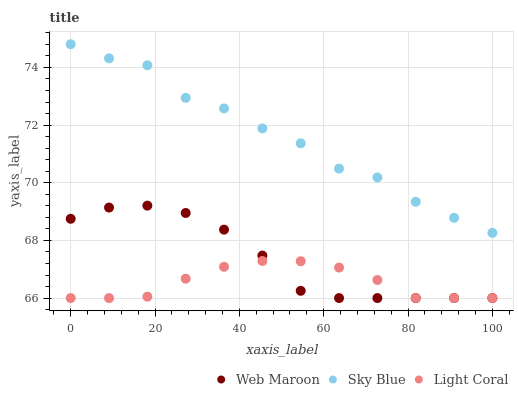Does Light Coral have the minimum area under the curve?
Answer yes or no. Yes. Does Sky Blue have the maximum area under the curve?
Answer yes or no. Yes. Does Web Maroon have the minimum area under the curve?
Answer yes or no. No. Does Web Maroon have the maximum area under the curve?
Answer yes or no. No. Is Light Coral the smoothest?
Answer yes or no. Yes. Is Sky Blue the roughest?
Answer yes or no. Yes. Is Web Maroon the smoothest?
Answer yes or no. No. Is Web Maroon the roughest?
Answer yes or no. No. Does Light Coral have the lowest value?
Answer yes or no. Yes. Does Sky Blue have the lowest value?
Answer yes or no. No. Does Sky Blue have the highest value?
Answer yes or no. Yes. Does Web Maroon have the highest value?
Answer yes or no. No. Is Web Maroon less than Sky Blue?
Answer yes or no. Yes. Is Sky Blue greater than Web Maroon?
Answer yes or no. Yes. Does Web Maroon intersect Light Coral?
Answer yes or no. Yes. Is Web Maroon less than Light Coral?
Answer yes or no. No. Is Web Maroon greater than Light Coral?
Answer yes or no. No. Does Web Maroon intersect Sky Blue?
Answer yes or no. No. 